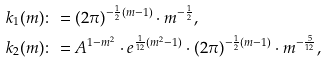<formula> <loc_0><loc_0><loc_500><loc_500>& k _ { 1 } ( m ) \colon = ( 2 \pi ) ^ { - \frac { 1 } { 2 } ( m - 1 ) } \cdot m ^ { - \frac { 1 } { 2 } } , \\ & k _ { 2 } ( m ) \colon = A ^ { 1 - m ^ { 2 } } \cdot e ^ { \frac { 1 } { 1 2 } ( m ^ { 2 } - 1 ) } \cdot ( 2 \pi ) ^ { - \frac { 1 } { 2 } ( m - 1 ) } \cdot m ^ { - \frac { 5 } { 1 2 } } ,</formula> 